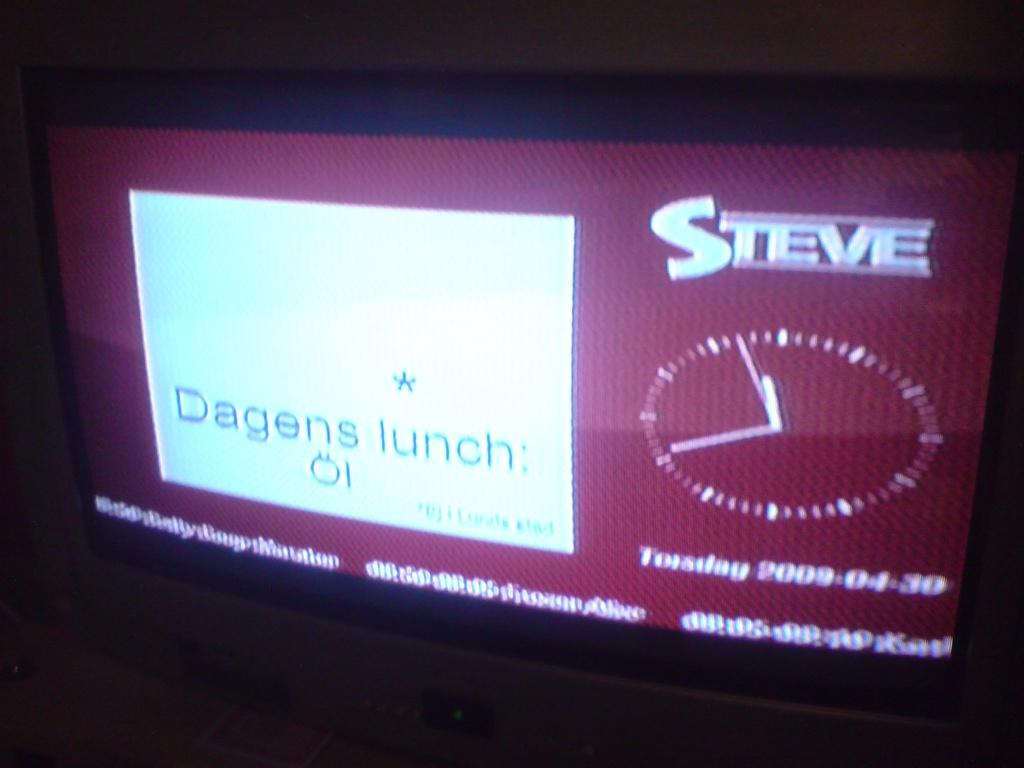<image>
Write a terse but informative summary of the picture. A screen that says Dagens lunch on it and Steve in the corner. 